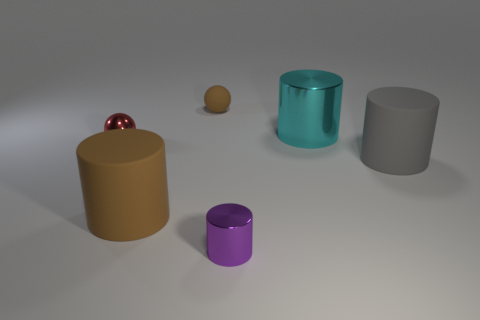There is a small metallic object that is to the right of the brown object in front of the tiny metal ball; what number of tiny purple cylinders are in front of it?
Offer a terse response. 0. Does the ball on the left side of the rubber ball have the same color as the large shiny thing?
Provide a short and direct response. No. What number of other things are the same shape as the big brown thing?
Keep it short and to the point. 3. How many other things are made of the same material as the small cylinder?
Offer a terse response. 2. What material is the big thing to the left of the small rubber sphere behind the tiny shiny object in front of the gray cylinder?
Ensure brevity in your answer.  Rubber. Does the small brown thing have the same material as the large brown cylinder?
Provide a short and direct response. Yes. What number of spheres are brown objects or gray things?
Provide a succinct answer. 1. What color is the tiny metallic object that is on the right side of the big brown thing?
Provide a succinct answer. Purple. What number of metallic objects are either tiny purple cylinders or cyan cylinders?
Keep it short and to the point. 2. There is a large thing that is behind the small ball left of the small brown rubber thing; what is its material?
Your response must be concise. Metal. 